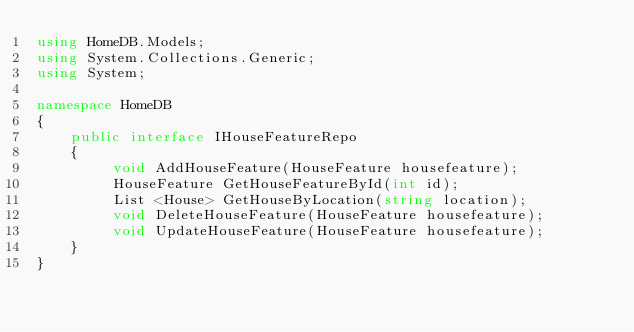<code> <loc_0><loc_0><loc_500><loc_500><_C#_>using HomeDB.Models;
using System.Collections.Generic;
using System;

namespace HomeDB
{
    public interface IHouseFeatureRepo
    {
         void AddHouseFeature(HouseFeature housefeature);
         HouseFeature GetHouseFeatureById(int id);
         List <House> GetHouseByLocation(string location);
         void DeleteHouseFeature(HouseFeature housefeature);
         void UpdateHouseFeature(HouseFeature housefeature);
    }
}</code> 